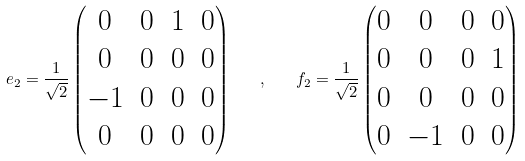<formula> <loc_0><loc_0><loc_500><loc_500>e _ { 2 } = \frac { 1 } { \sqrt { 2 } } \begin{pmatrix} 0 & 0 & 1 & 0 \\ 0 & 0 & 0 & 0 \\ - 1 & 0 & 0 & 0 \\ 0 & 0 & 0 & 0 \\ \end{pmatrix} \quad , \quad f _ { 2 } = \frac { 1 } { \sqrt { 2 } } \begin{pmatrix} 0 & 0 & 0 & 0 \\ 0 & 0 & 0 & 1 \\ 0 & 0 & 0 & 0 \\ 0 & - 1 & 0 & 0 \\ \end{pmatrix} \,</formula> 